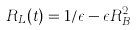<formula> <loc_0><loc_0><loc_500><loc_500>R _ { L } ( t ) = 1 / \epsilon - \epsilon R _ { B } ^ { 2 }</formula> 